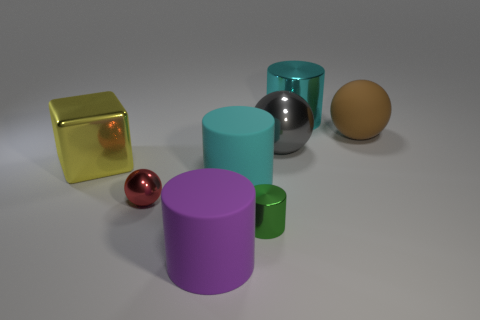Subtract all green cylinders. How many cylinders are left? 3 Subtract all large cyan rubber cylinders. How many cylinders are left? 3 Subtract 1 cylinders. How many cylinders are left? 3 Subtract all brown cylinders. Subtract all green cubes. How many cylinders are left? 4 Add 2 big cyan matte cylinders. How many objects exist? 10 Subtract all blocks. How many objects are left? 7 Add 3 rubber things. How many rubber things are left? 6 Add 4 purple things. How many purple things exist? 5 Subtract 0 purple spheres. How many objects are left? 8 Subtract all large purple matte objects. Subtract all tiny yellow metal cylinders. How many objects are left? 7 